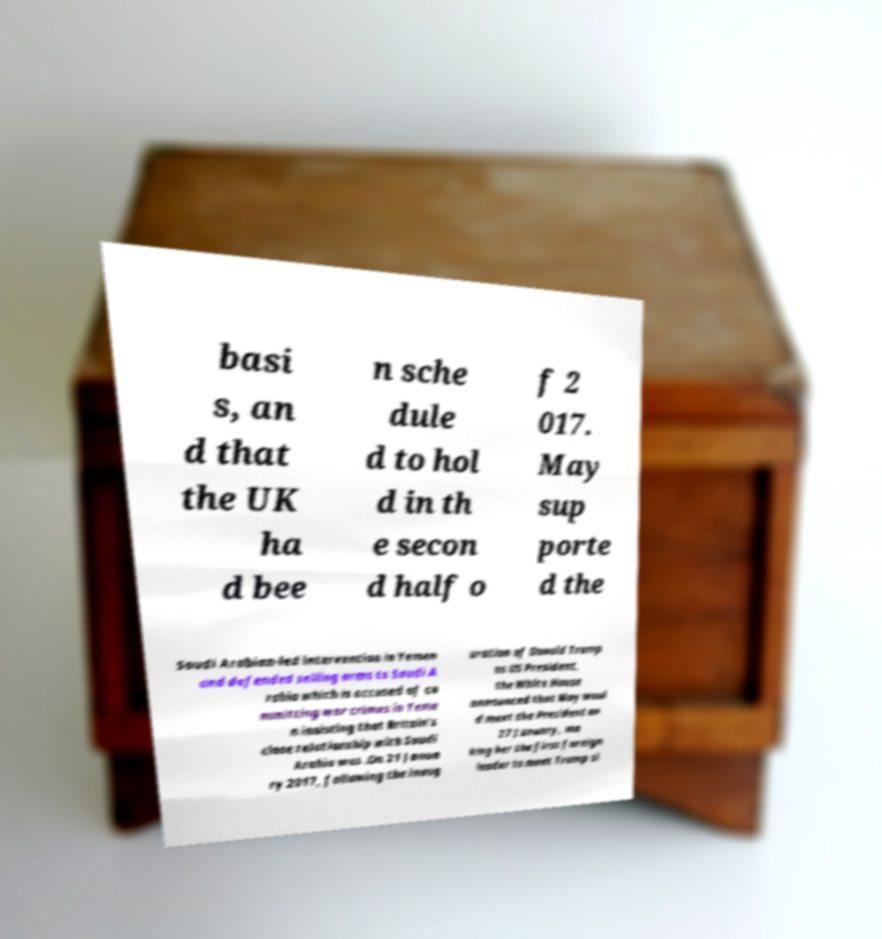I need the written content from this picture converted into text. Can you do that? basi s, an d that the UK ha d bee n sche dule d to hol d in th e secon d half o f 2 017. May sup porte d the Saudi Arabian-led intervention in Yemen and defended selling arms to Saudi A rabia which is accused of co mmitting war crimes in Yeme n insisting that Britain's close relationship with Saudi Arabia was .On 21 Janua ry 2017, following the inaug uration of Donald Trump as US President, the White House announced that May woul d meet the President on 27 January, ma king her the first foreign leader to meet Trump si 